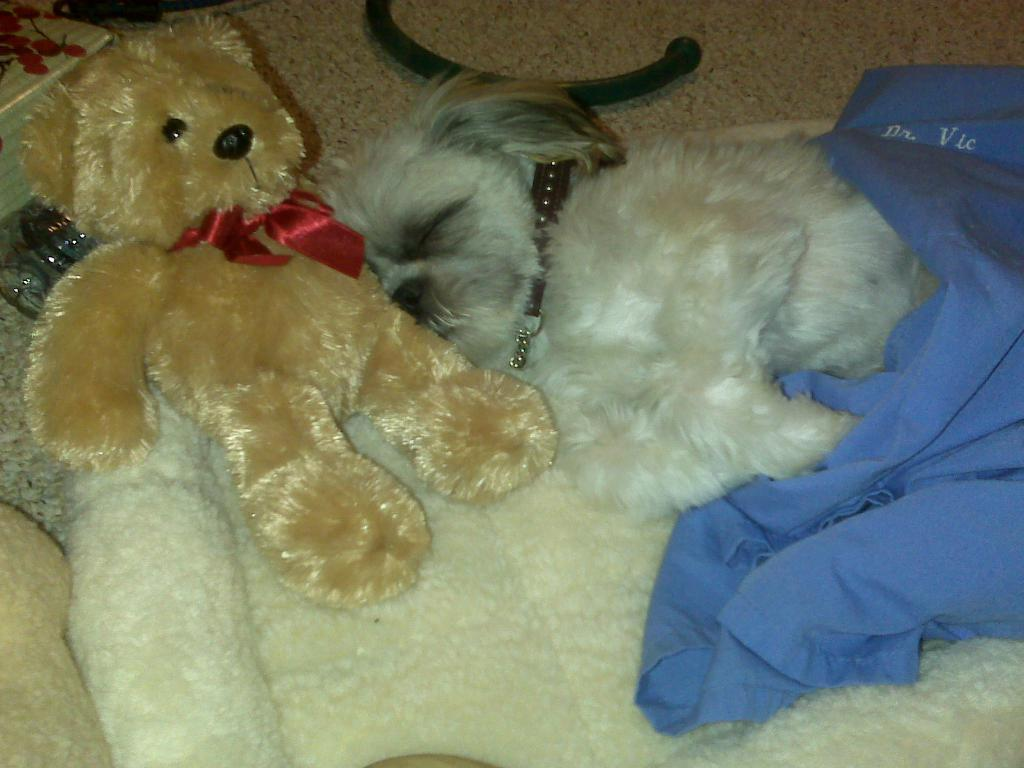What type of toy is in the image? There is a toy in the image, but the specific type is not mentioned. What animal is present in the image? There is a dog in the image. What type of flooring is visible in the image? The image contains a carpet. What is specifically designed for the dog in the image? There is a dog mat in the image. What type of material is present in the image? The image contains cloth. What type of container is in the image? There is a glass in the image. Can you describe any other objects in the image? There are other objects in the image, but their specific types are not mentioned. What type of jail is visible in the image? There is no jail present in the image. What type of badge is the dog wearing in the image? There is no badge present in the image, and the dog is not wearing any clothing or accessories. 